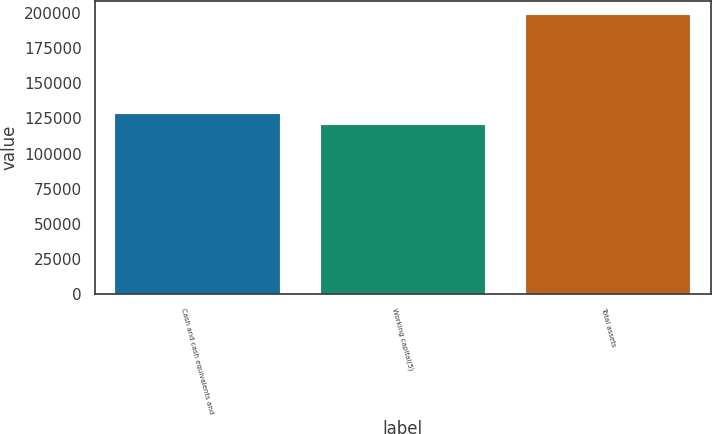Convert chart to OTSL. <chart><loc_0><loc_0><loc_500><loc_500><bar_chart><fcel>Cash and cash equivalents and<fcel>Working capital(5)<fcel>Total assets<nl><fcel>128427<fcel>120656<fcel>198366<nl></chart> 